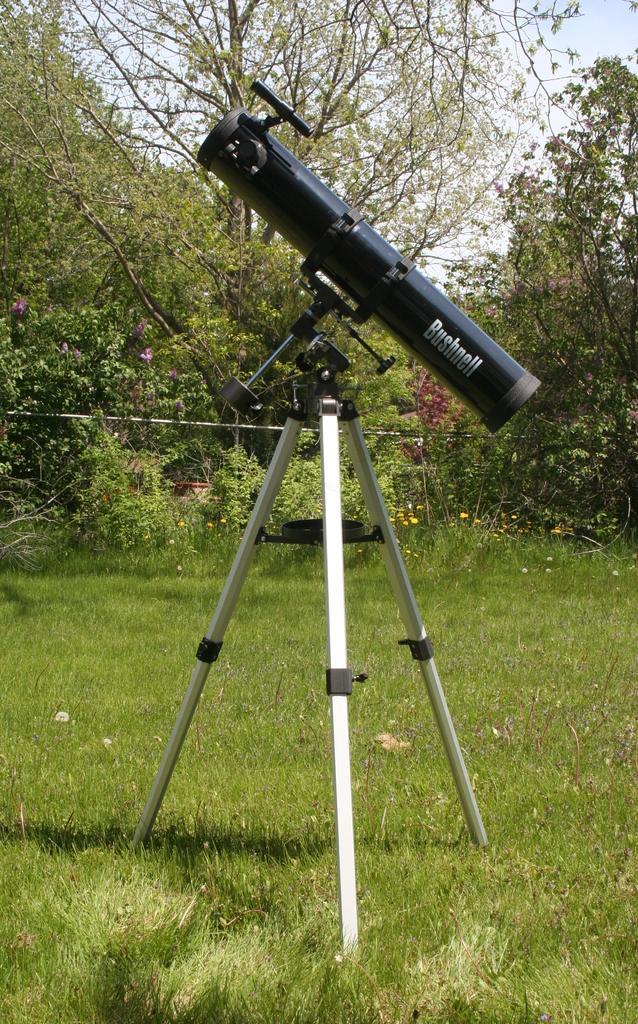Describe this image in one or two sentences. In this image we can see a binocular to a stand and the stand is in the grass, there are few trees, a few flowers, few plants. 